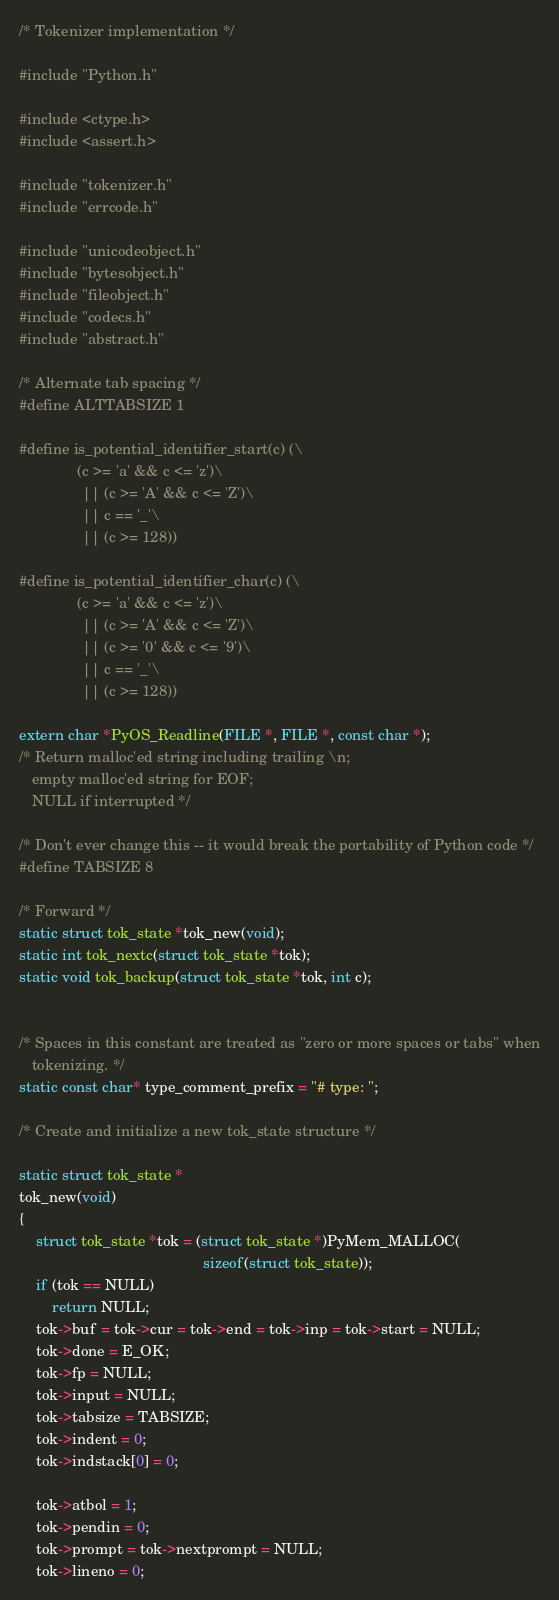Convert code to text. <code><loc_0><loc_0><loc_500><loc_500><_C_>
/* Tokenizer implementation */

#include "Python.h"

#include <ctype.h>
#include <assert.h>

#include "tokenizer.h"
#include "errcode.h"

#include "unicodeobject.h"
#include "bytesobject.h"
#include "fileobject.h"
#include "codecs.h"
#include "abstract.h"

/* Alternate tab spacing */
#define ALTTABSIZE 1

#define is_potential_identifier_start(c) (\
              (c >= 'a' && c <= 'z')\
               || (c >= 'A' && c <= 'Z')\
               || c == '_'\
               || (c >= 128))

#define is_potential_identifier_char(c) (\
              (c >= 'a' && c <= 'z')\
               || (c >= 'A' && c <= 'Z')\
               || (c >= '0' && c <= '9')\
               || c == '_'\
               || (c >= 128))

extern char *PyOS_Readline(FILE *, FILE *, const char *);
/* Return malloc'ed string including trailing \n;
   empty malloc'ed string for EOF;
   NULL if interrupted */

/* Don't ever change this -- it would break the portability of Python code */
#define TABSIZE 8

/* Forward */
static struct tok_state *tok_new(void);
static int tok_nextc(struct tok_state *tok);
static void tok_backup(struct tok_state *tok, int c);


/* Spaces in this constant are treated as "zero or more spaces or tabs" when
   tokenizing. */
static const char* type_comment_prefix = "# type: ";

/* Create and initialize a new tok_state structure */

static struct tok_state *
tok_new(void)
{
    struct tok_state *tok = (struct tok_state *)PyMem_MALLOC(
                                            sizeof(struct tok_state));
    if (tok == NULL)
        return NULL;
    tok->buf = tok->cur = tok->end = tok->inp = tok->start = NULL;
    tok->done = E_OK;
    tok->fp = NULL;
    tok->input = NULL;
    tok->tabsize = TABSIZE;
    tok->indent = 0;
    tok->indstack[0] = 0;

    tok->atbol = 1;
    tok->pendin = 0;
    tok->prompt = tok->nextprompt = NULL;
    tok->lineno = 0;</code> 